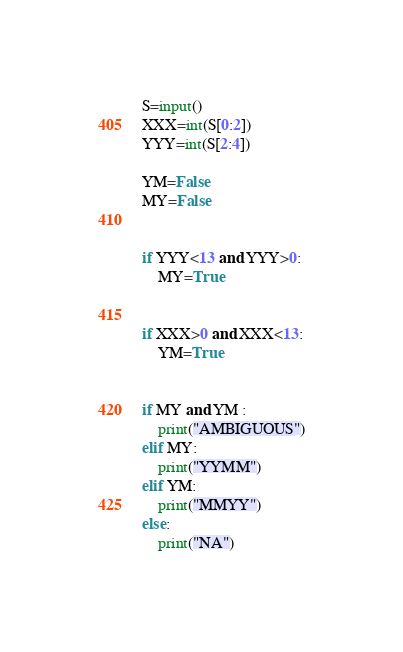<code> <loc_0><loc_0><loc_500><loc_500><_Python_>S=input()
XXX=int(S[0:2])
YYY=int(S[2:4])

YM=False
MY=False


if YYY<13 and YYY>0:
	MY=True


if XXX>0 and XXX<13:
	YM=True


if MY and YM :
	print("AMBIGUOUS")
elif MY:
	print("YYMM")
elif YM:
	print("MMYY")
else:
	print("NA")</code> 